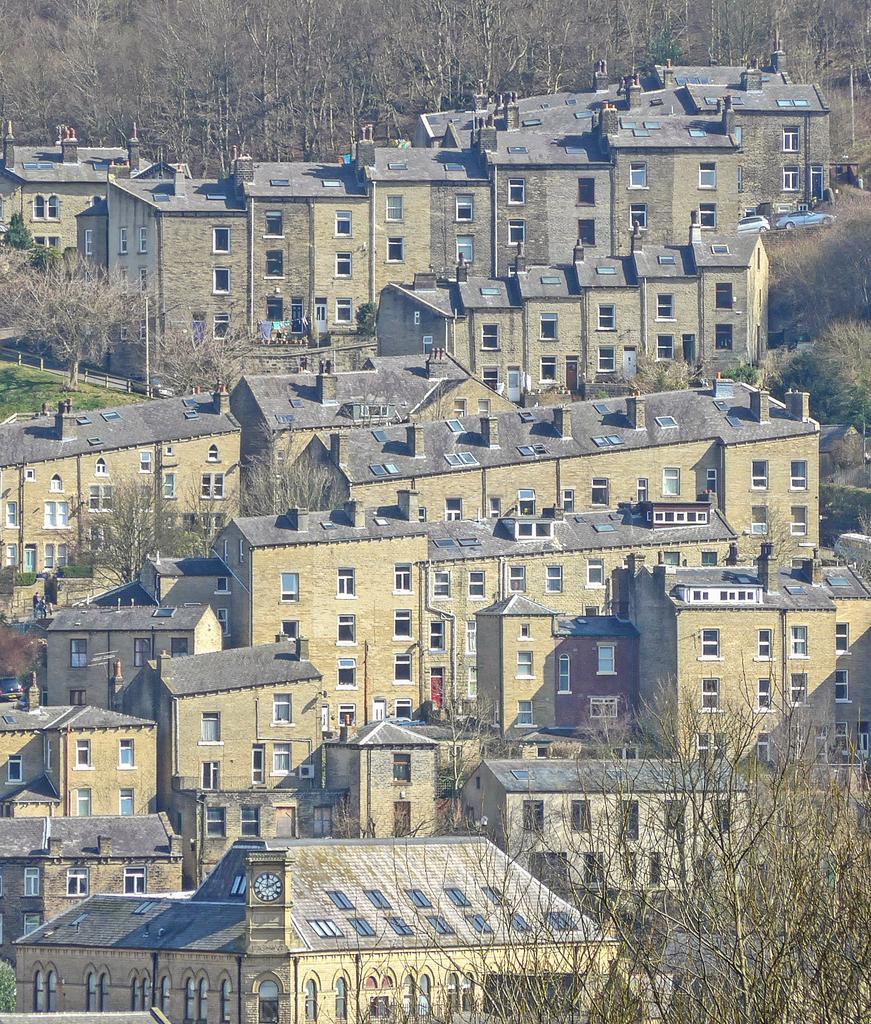Describe this image in one or two sentences. This is a top view of a part of a city. I can see buildings and trees all over the image. 